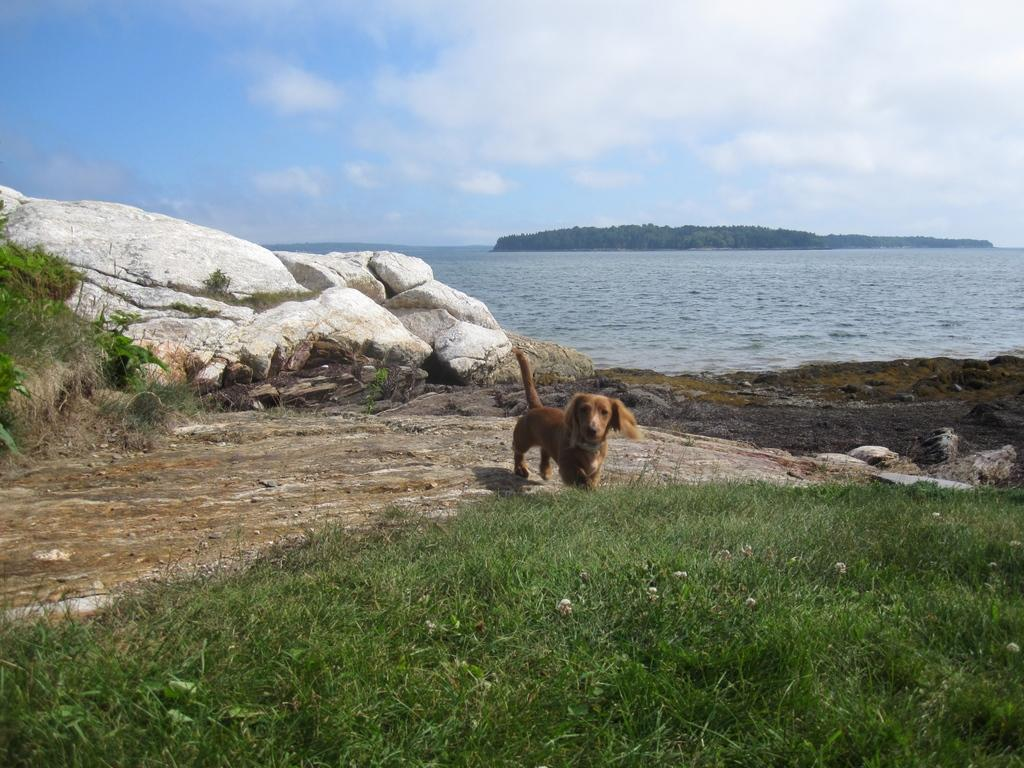What is located in the middle of the image? There is water in the middle of the image. What type of vegetation can be seen at the bottom of the image? There is grass at the bottom of the image. What animal is present in the image? There is a dog in the middle of the image. What is visible at the top of the image? The sky is visible at the top of the image. What type of wrench is being used to clean the dog's teeth in the image? There is no wrench or toothpaste present in the image; it features water, grass, a dog, and sky. How much power is being generated by the dog in the image? There is no indication of power generation in the image, as it is focused on the dog, water, grass, and sky. 